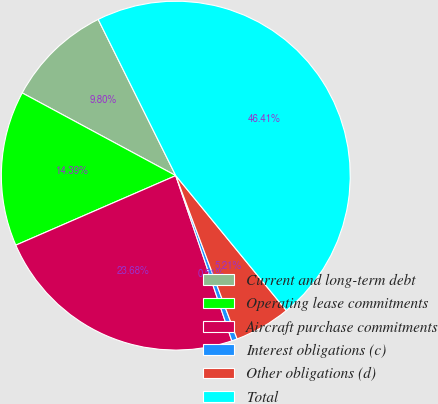Convert chart. <chart><loc_0><loc_0><loc_500><loc_500><pie_chart><fcel>Current and long-term debt<fcel>Operating lease commitments<fcel>Aircraft purchase commitments<fcel>Interest obligations (c)<fcel>Other obligations (d)<fcel>Total<nl><fcel>9.8%<fcel>14.39%<fcel>23.68%<fcel>0.51%<fcel>5.21%<fcel>46.41%<nl></chart> 